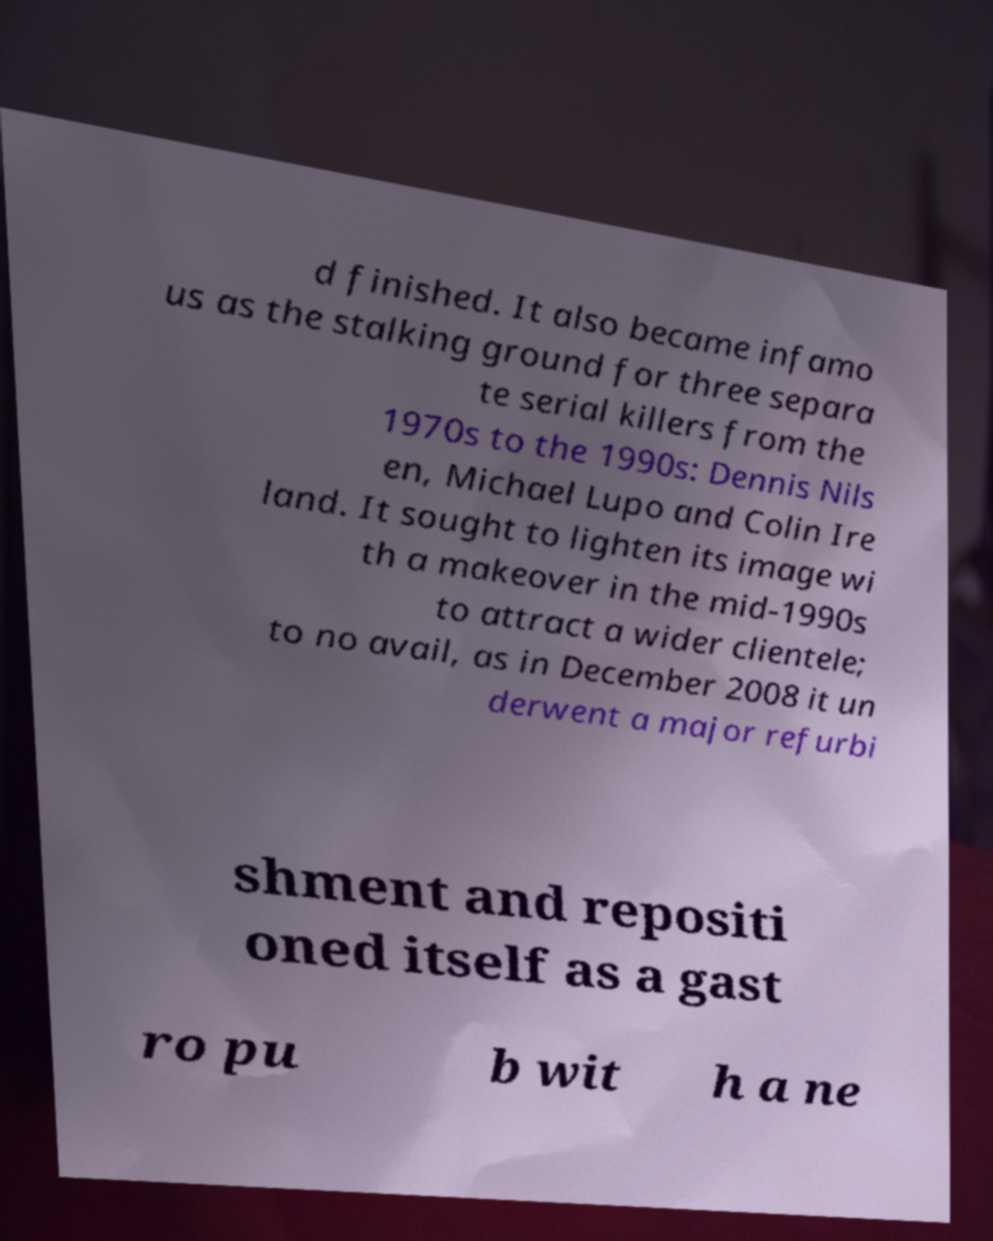What messages or text are displayed in this image? I need them in a readable, typed format. d finished. It also became infamo us as the stalking ground for three separa te serial killers from the 1970s to the 1990s: Dennis Nils en, Michael Lupo and Colin Ire land. It sought to lighten its image wi th a makeover in the mid-1990s to attract a wider clientele; to no avail, as in December 2008 it un derwent a major refurbi shment and repositi oned itself as a gast ro pu b wit h a ne 